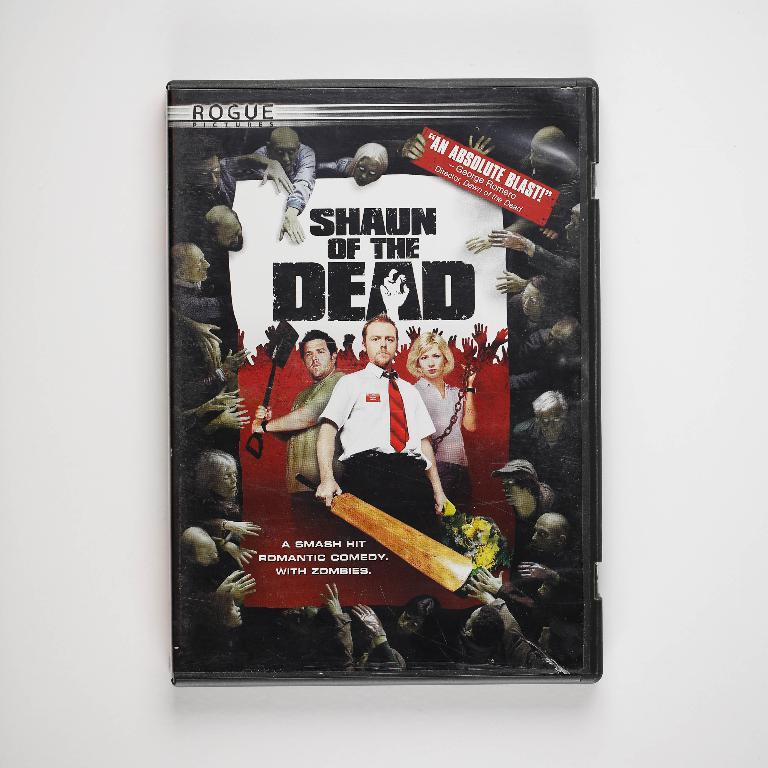<image>
Create a compact narrative representing the image presented. A poster for the movie Shaun of the Dead. 